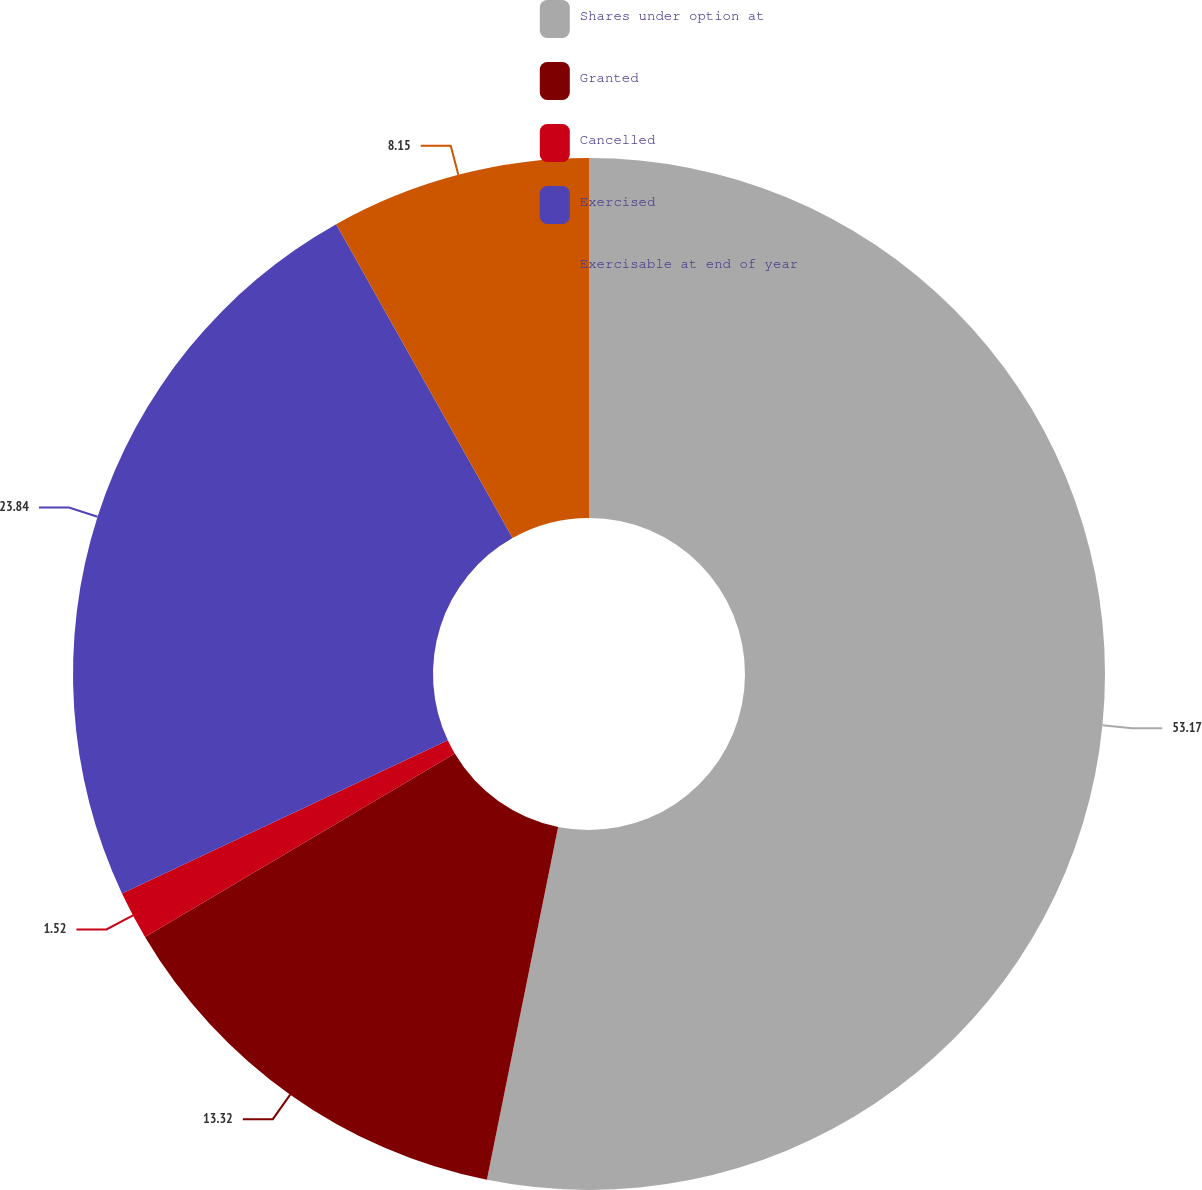Convert chart. <chart><loc_0><loc_0><loc_500><loc_500><pie_chart><fcel>Shares under option at<fcel>Granted<fcel>Cancelled<fcel>Exercised<fcel>Exercisable at end of year<nl><fcel>53.17%<fcel>13.32%<fcel>1.52%<fcel>23.84%<fcel>8.15%<nl></chart> 